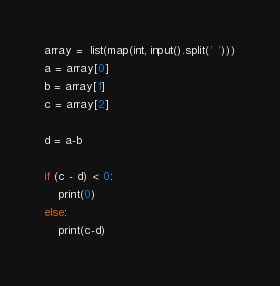Convert code to text. <code><loc_0><loc_0><loc_500><loc_500><_Python_>array =  list(map(int, input().split(' ')))
a = array[0]
b = array[1]
c = array[2]

d = a-b

if (c - d) < 0:
    print(0)
else:
    print(c-d)</code> 